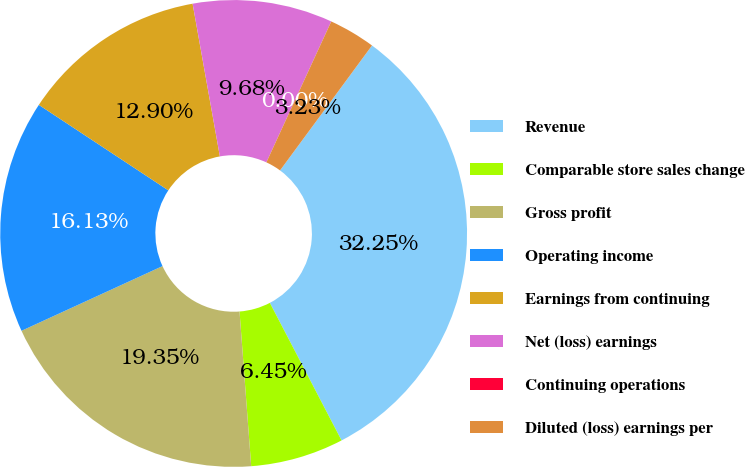<chart> <loc_0><loc_0><loc_500><loc_500><pie_chart><fcel>Revenue<fcel>Comparable store sales change<fcel>Gross profit<fcel>Operating income<fcel>Earnings from continuing<fcel>Net (loss) earnings<fcel>Continuing operations<fcel>Diluted (loss) earnings per<nl><fcel>32.25%<fcel>6.45%<fcel>19.35%<fcel>16.13%<fcel>12.9%<fcel>9.68%<fcel>0.0%<fcel>3.23%<nl></chart> 